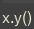<code> <loc_0><loc_0><loc_500><loc_500><_JavaScript_>x.y()
</code> 